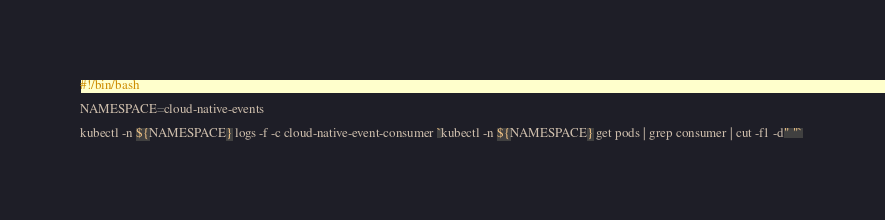<code> <loc_0><loc_0><loc_500><loc_500><_Bash_>#!/bin/bash

NAMESPACE=cloud-native-events

kubectl -n ${NAMESPACE} logs -f -c cloud-native-event-consumer `kubectl -n ${NAMESPACE} get pods | grep consumer | cut -f1 -d" "` 
</code> 